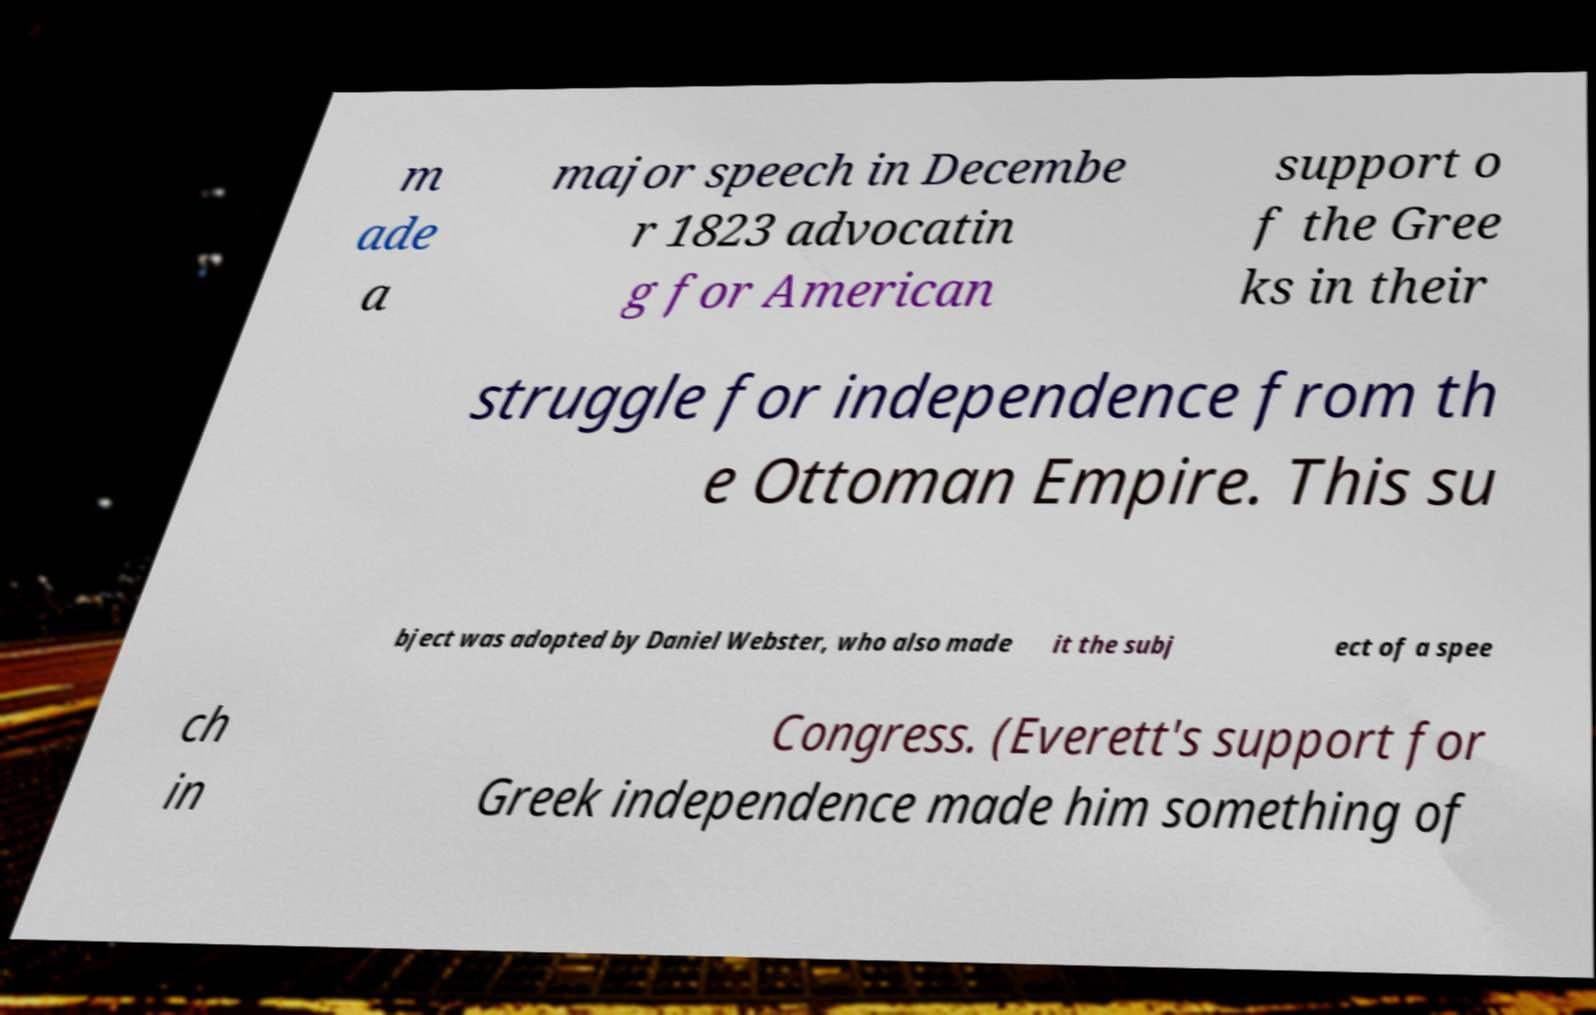I need the written content from this picture converted into text. Can you do that? m ade a major speech in Decembe r 1823 advocatin g for American support o f the Gree ks in their struggle for independence from th e Ottoman Empire. This su bject was adopted by Daniel Webster, who also made it the subj ect of a spee ch in Congress. (Everett's support for Greek independence made him something of 